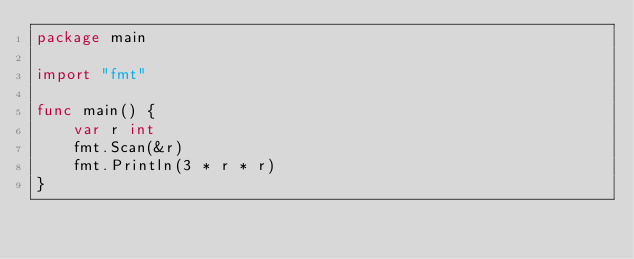Convert code to text. <code><loc_0><loc_0><loc_500><loc_500><_Go_>package main

import "fmt"

func main() {
	var r int
	fmt.Scan(&r)
	fmt.Println(3 * r * r)
}
</code> 